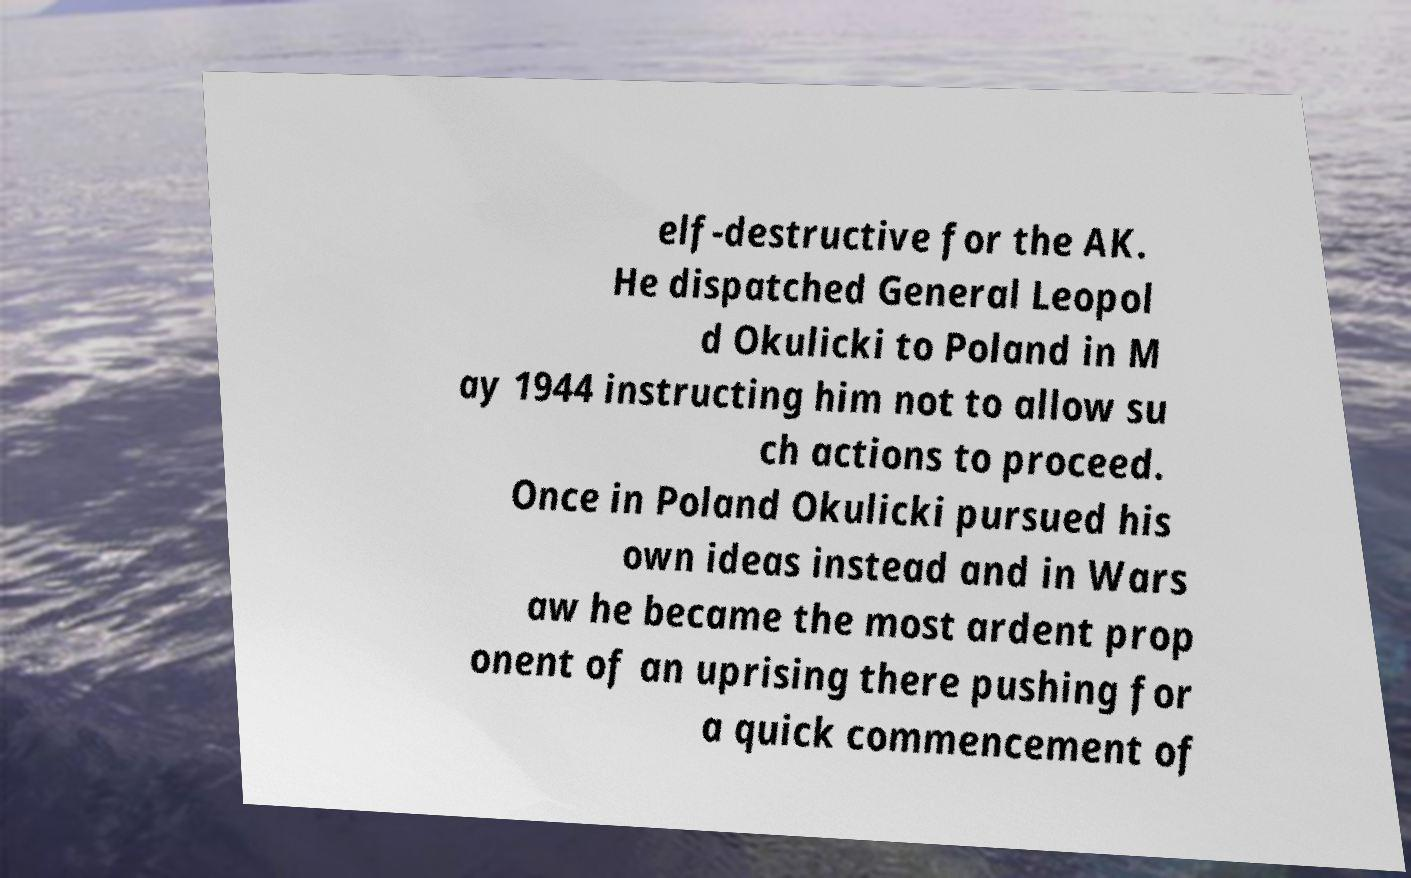For documentation purposes, I need the text within this image transcribed. Could you provide that? elf-destructive for the AK. He dispatched General Leopol d Okulicki to Poland in M ay 1944 instructing him not to allow su ch actions to proceed. Once in Poland Okulicki pursued his own ideas instead and in Wars aw he became the most ardent prop onent of an uprising there pushing for a quick commencement of 